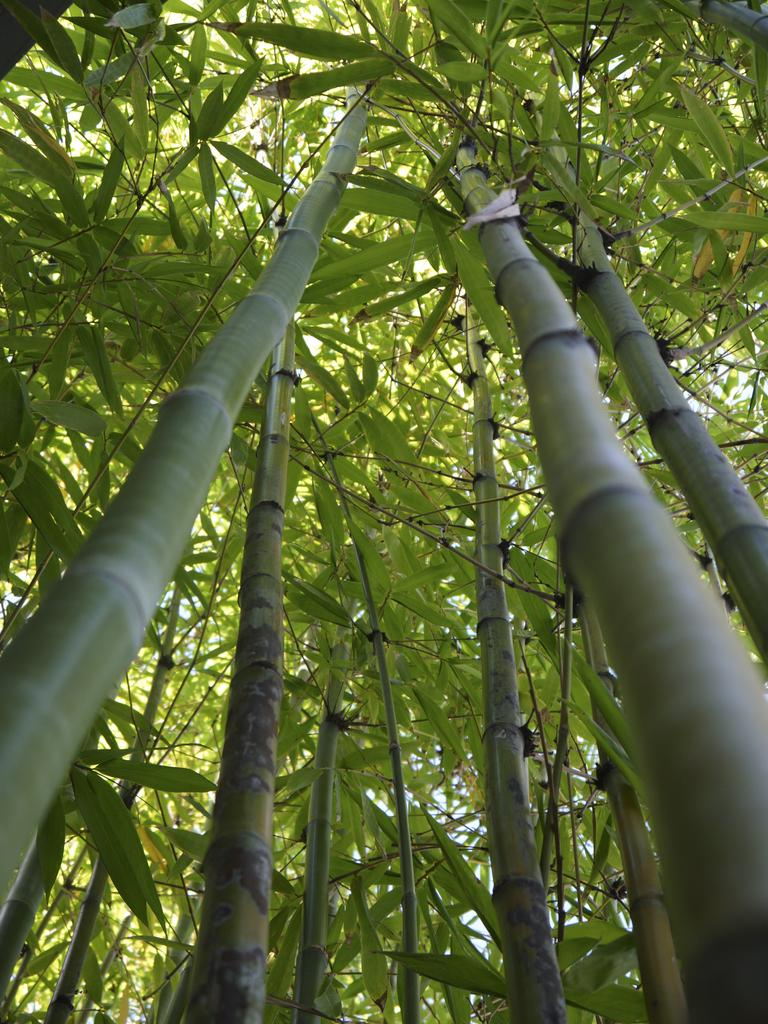What type of trees are present in the image? There are bamboo trees in the image. What can be observed on the bamboo trees? There are leaves on the bamboo trees. What language is being spoken by the bamboo trees in the image? Bamboo trees do not speak any language, as they are plants and do not have the ability to communicate verbally. 